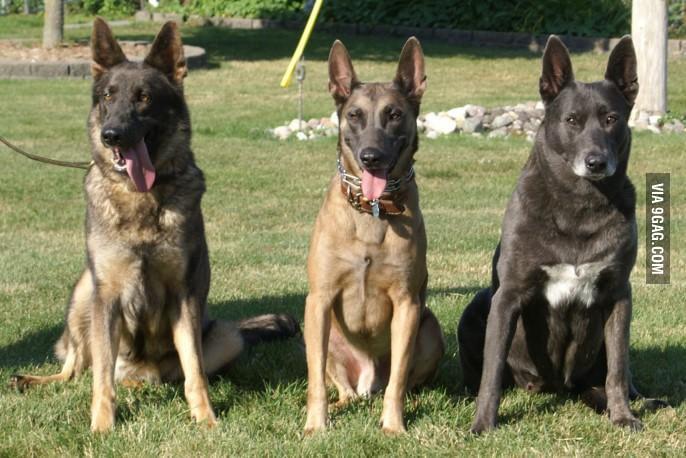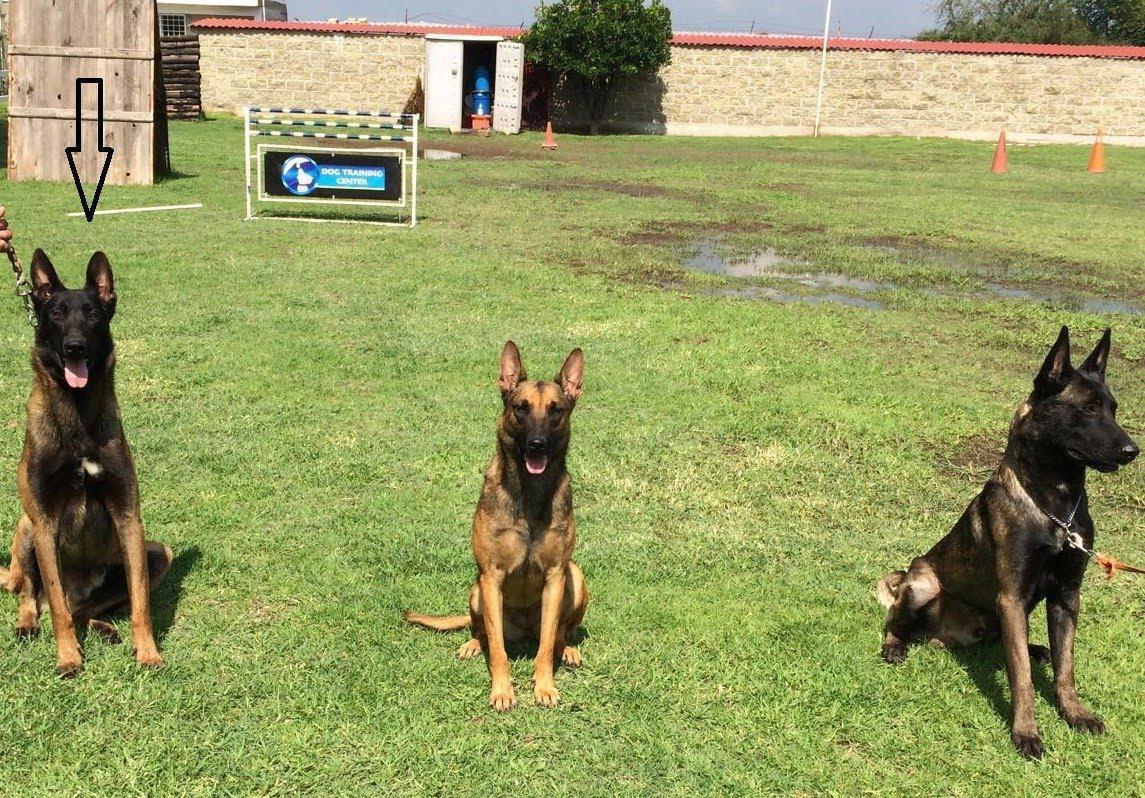The first image is the image on the left, the second image is the image on the right. For the images shown, is this caption "There is exactly three dogs in the left image." true? Answer yes or no. Yes. The first image is the image on the left, the second image is the image on the right. Given the left and right images, does the statement "Every photograph shows exactly three German Shepard dogs photographed outside, with at least two dogs on the left hand side sticking their tongues out." hold true? Answer yes or no. Yes. 